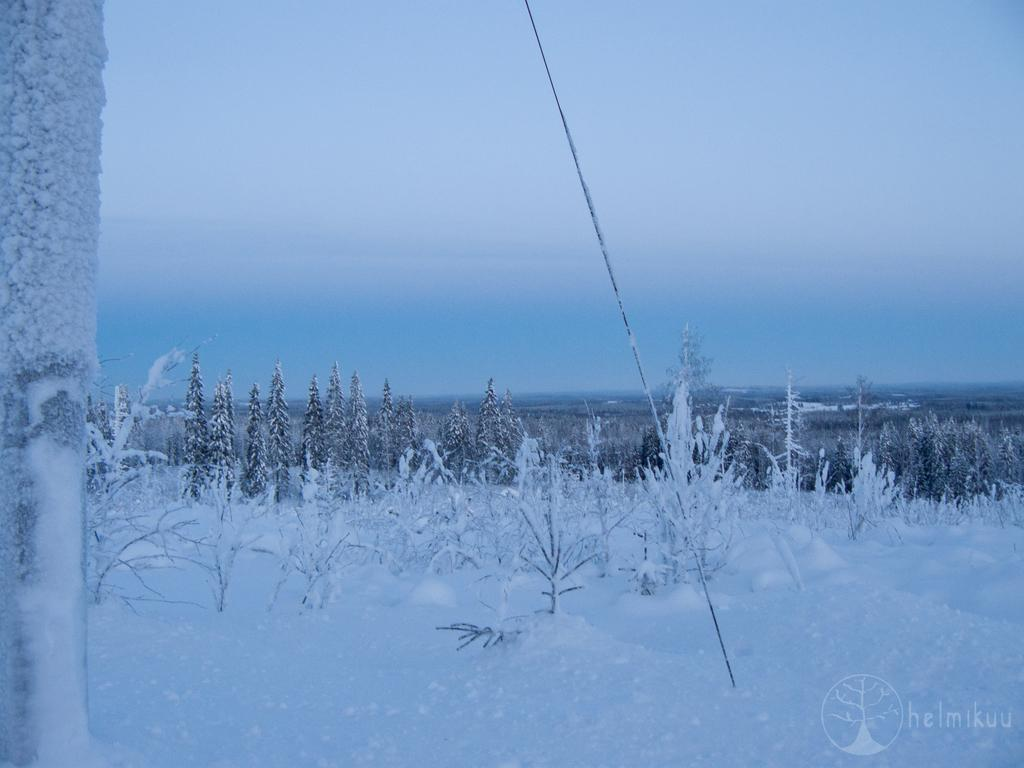What is covering the ground in the image? There is snow on the ground in the image. What can be seen in the distance in the image? There are trees visible in the background of the image. What type of bag is being observed in the image? There is no bag present in the image. Are there any boots visible in the image? There is no mention of boots in the provided facts, so we cannot determine if any are visible in the image. 